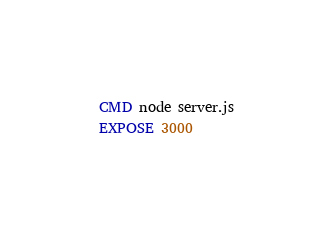Convert code to text. <code><loc_0><loc_0><loc_500><loc_500><_Dockerfile_>CMD node server.js
EXPOSE 3000
</code> 